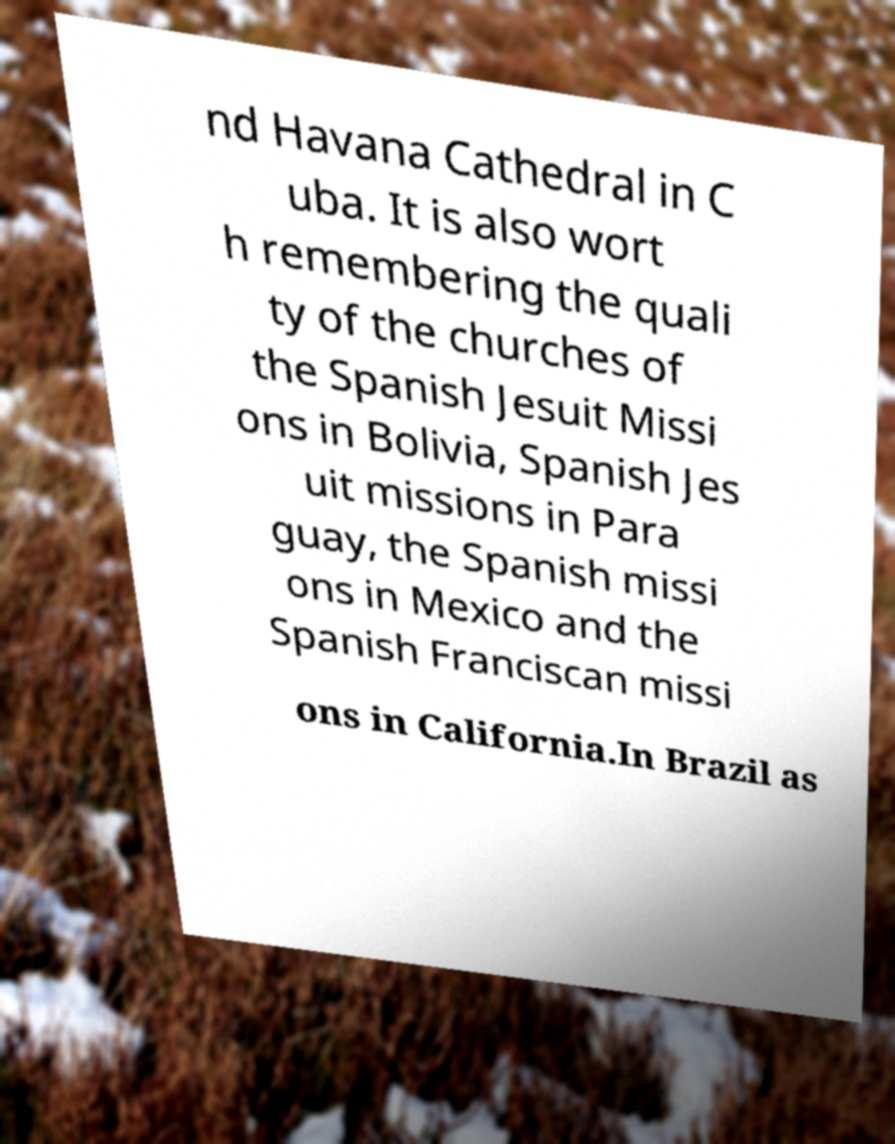Could you extract and type out the text from this image? nd Havana Cathedral in C uba. It is also wort h remembering the quali ty of the churches of the Spanish Jesuit Missi ons in Bolivia, Spanish Jes uit missions in Para guay, the Spanish missi ons in Mexico and the Spanish Franciscan missi ons in California.In Brazil as 